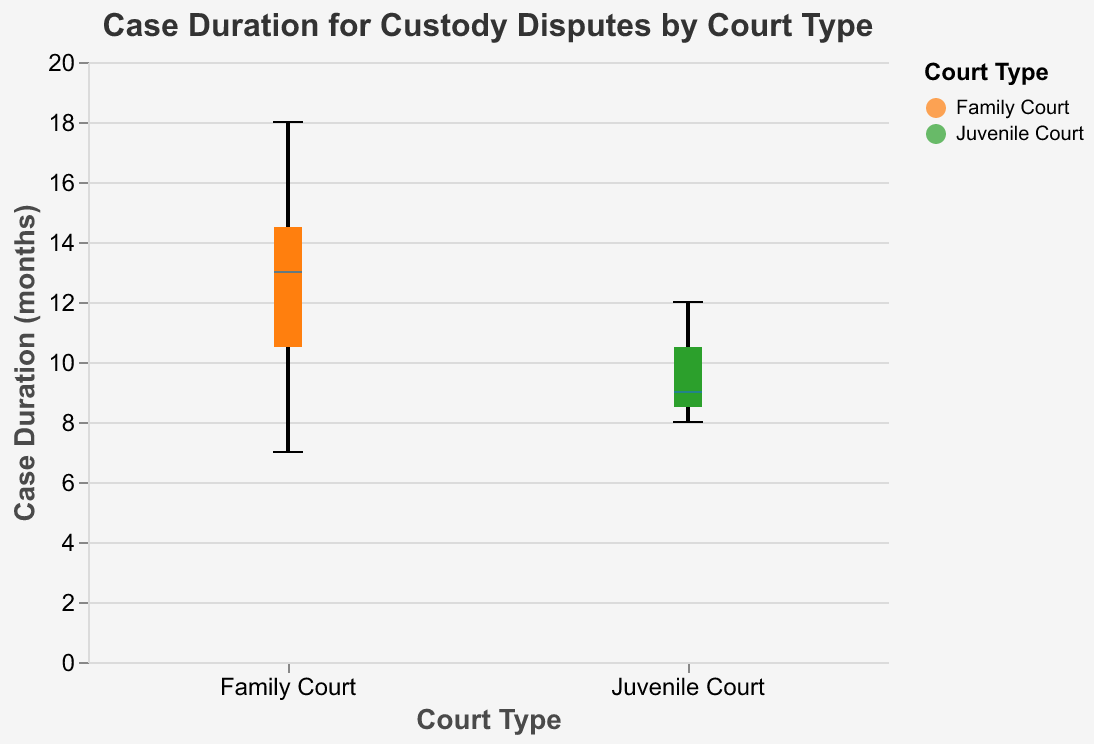What is the title of the figure? The title is located at the top of the figure and reads "Case Duration for Custody Disputes by Court Type."
Answer: Case Duration for Custody Disputes by Court Type Which court type has a wider range of case duration? Look at the horizontal spread of the boxes for each court type. Family Court has a boxplot that stretches from 7 to 18 months, while Juvenile Court ranges from 8 to 12 months. Family Court has a more extensive range.
Answer: Family Court What is the median case duration for Family Court? The median is represented by the bold line inside the box for Family Court. For Family Court, this line is at the 13-month mark.
Answer: 13 months How does the median duration of Family Court compare to Juvenile Court? The median for Family Court is at 13 months, shown as a thicker line. For Juvenile Court, the line is at 9 months.
Answer: Family Court's median is higher than Juvenile Court's What is the shortest case duration in the Juvenile Court? Identify the bottom whisker of the boxplot for Juvenile Court, indicating the minimum value. This value is 8 months.
Answer: 8 months Which court type has a larger interquartile range (IQR)? IQR is the distance between the bottom and top of the box (Q1 and Q3). For Family Court, IQR is from 10 to 15 months (5 months), while for Juvenile Court, it is from 9 to 11 months (2 months).
Answer: Family Court What is the case duration for the lower quartile of Family Court? The lower quartile (Q1) is the bottom of the box in a boxplot. For Family Court, the bottom of the box is at 10 months.
Answer: 10 months Does any of the court types have outliers? Outliers would be represented as dots outside the whiskers of the boxplot. Since there are no dots beyond the whiskers in either Family Court or Juvenile Court, there are no outliers.
Answer: No What is the maximum case duration for Family Court? The maximum value is indicated by the top whisker of the Family Court boxplot, which is at 18 months.
Answer: 18 months Calculate the IQR for Juvenile Court. The IQR is found by subtracting Q1 from Q3. For Juvenile Court, Q3 is 11 months, and Q1 is 9 months. So, 11 - 9 = 2 months.
Answer: 2 months 